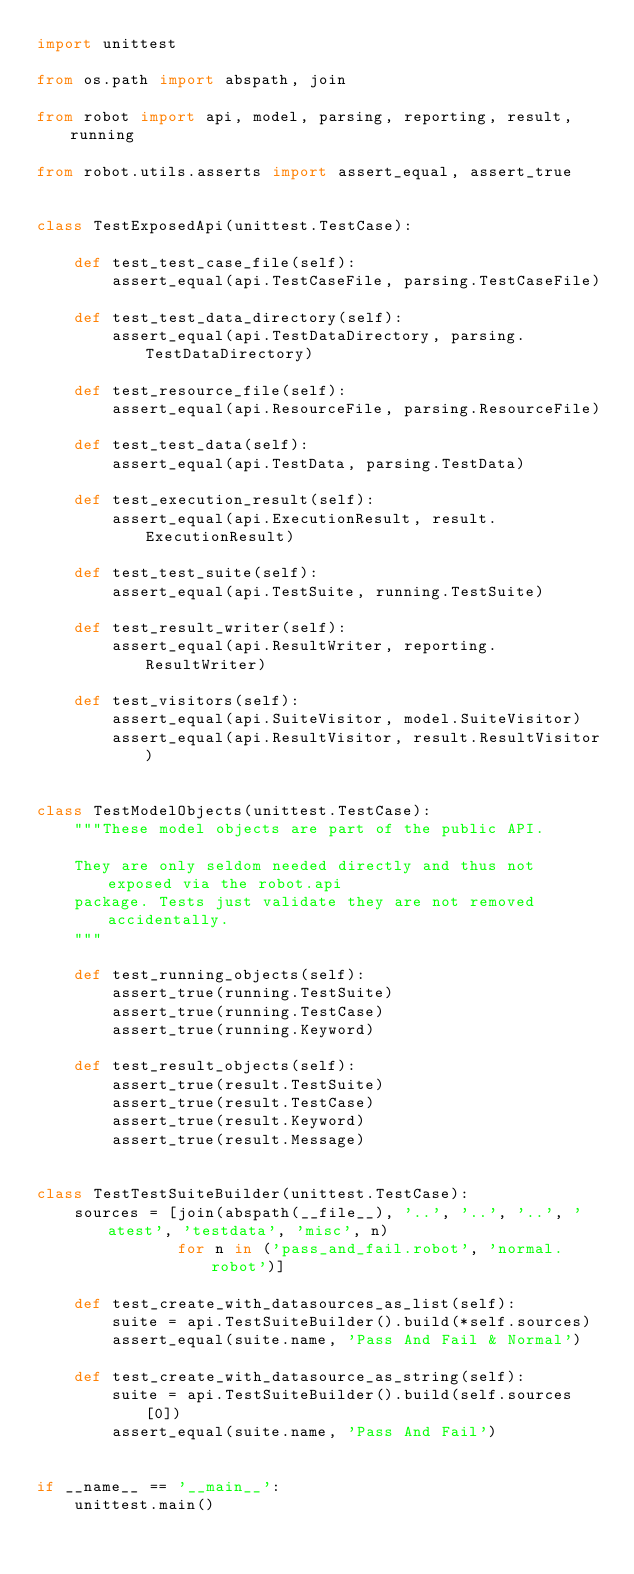Convert code to text. <code><loc_0><loc_0><loc_500><loc_500><_Python_>import unittest

from os.path import abspath, join

from robot import api, model, parsing, reporting, result, running

from robot.utils.asserts import assert_equal, assert_true


class TestExposedApi(unittest.TestCase):

    def test_test_case_file(self):
        assert_equal(api.TestCaseFile, parsing.TestCaseFile)

    def test_test_data_directory(self):
        assert_equal(api.TestDataDirectory, parsing.TestDataDirectory)

    def test_resource_file(self):
        assert_equal(api.ResourceFile, parsing.ResourceFile)

    def test_test_data(self):
        assert_equal(api.TestData, parsing.TestData)

    def test_execution_result(self):
        assert_equal(api.ExecutionResult, result.ExecutionResult)

    def test_test_suite(self):
        assert_equal(api.TestSuite, running.TestSuite)

    def test_result_writer(self):
        assert_equal(api.ResultWriter, reporting.ResultWriter)

    def test_visitors(self):
        assert_equal(api.SuiteVisitor, model.SuiteVisitor)
        assert_equal(api.ResultVisitor, result.ResultVisitor)


class TestModelObjects(unittest.TestCase):
    """These model objects are part of the public API.

    They are only seldom needed directly and thus not exposed via the robot.api
    package. Tests just validate they are not removed accidentally.
    """

    def test_running_objects(self):
        assert_true(running.TestSuite)
        assert_true(running.TestCase)
        assert_true(running.Keyword)

    def test_result_objects(self):
        assert_true(result.TestSuite)
        assert_true(result.TestCase)
        assert_true(result.Keyword)
        assert_true(result.Message)


class TestTestSuiteBuilder(unittest.TestCase):
    sources = [join(abspath(__file__), '..', '..', '..', 'atest', 'testdata', 'misc', n)
               for n in ('pass_and_fail.robot', 'normal.robot')]

    def test_create_with_datasources_as_list(self):
        suite = api.TestSuiteBuilder().build(*self.sources)
        assert_equal(suite.name, 'Pass And Fail & Normal')

    def test_create_with_datasource_as_string(self):
        suite = api.TestSuiteBuilder().build(self.sources[0])
        assert_equal(suite.name, 'Pass And Fail')


if __name__ == '__main__':
    unittest.main()
</code> 